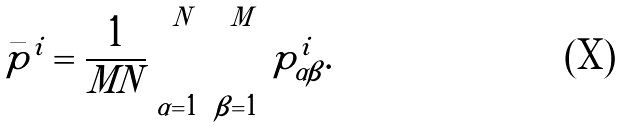Convert formula to latex. <formula><loc_0><loc_0><loc_500><loc_500>\bar { p } ^ { i } = \frac { 1 } { M N } \sum _ { \alpha = 1 } ^ { N } \sum _ { \beta = 1 } ^ { M } p ^ { i } _ { \alpha \beta } .</formula> 